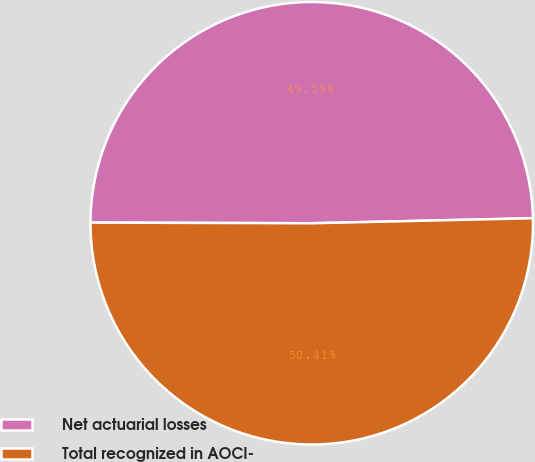Convert chart. <chart><loc_0><loc_0><loc_500><loc_500><pie_chart><fcel>Net actuarial losses<fcel>Total recognized in AOCI-<nl><fcel>49.59%<fcel>50.41%<nl></chart> 